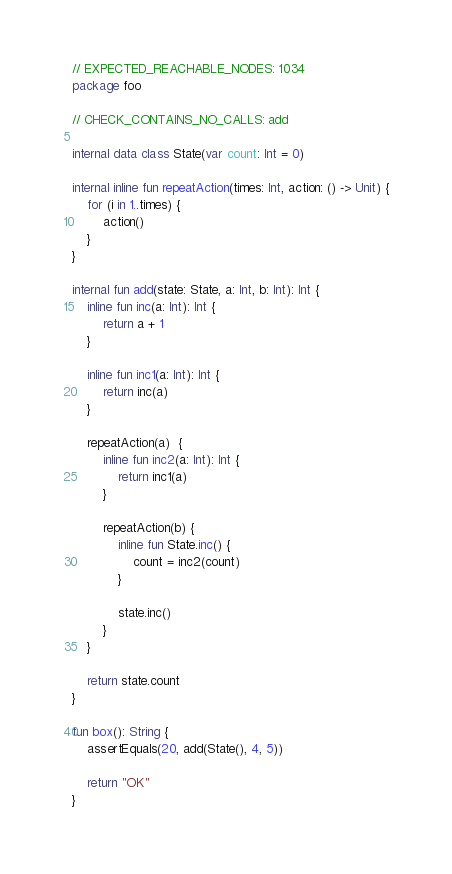<code> <loc_0><loc_0><loc_500><loc_500><_Kotlin_>// EXPECTED_REACHABLE_NODES: 1034
package foo

// CHECK_CONTAINS_NO_CALLS: add

internal data class State(var count: Int = 0)

internal inline fun repeatAction(times: Int, action: () -> Unit) {
    for (i in 1..times) {
        action()
    }
}

internal fun add(state: State, a: Int, b: Int): Int {
    inline fun inc(a: Int): Int {
        return a + 1
    }

    inline fun inc1(a: Int): Int {
        return inc(a)
    }

    repeatAction(a)  {
        inline fun inc2(a: Int): Int {
            return inc1(a)
        }

        repeatAction(b) {
            inline fun State.inc() {
                count = inc2(count)
            }

            state.inc()
        }
    }

    return state.count
}

fun box(): String {
    assertEquals(20, add(State(), 4, 5))

    return "OK"
}</code> 